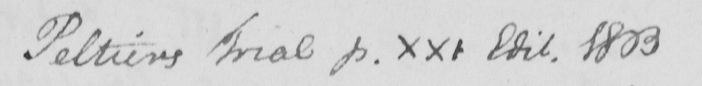Can you read and transcribe this handwriting? Peltiers Trial p . xxi Edit . 1803 